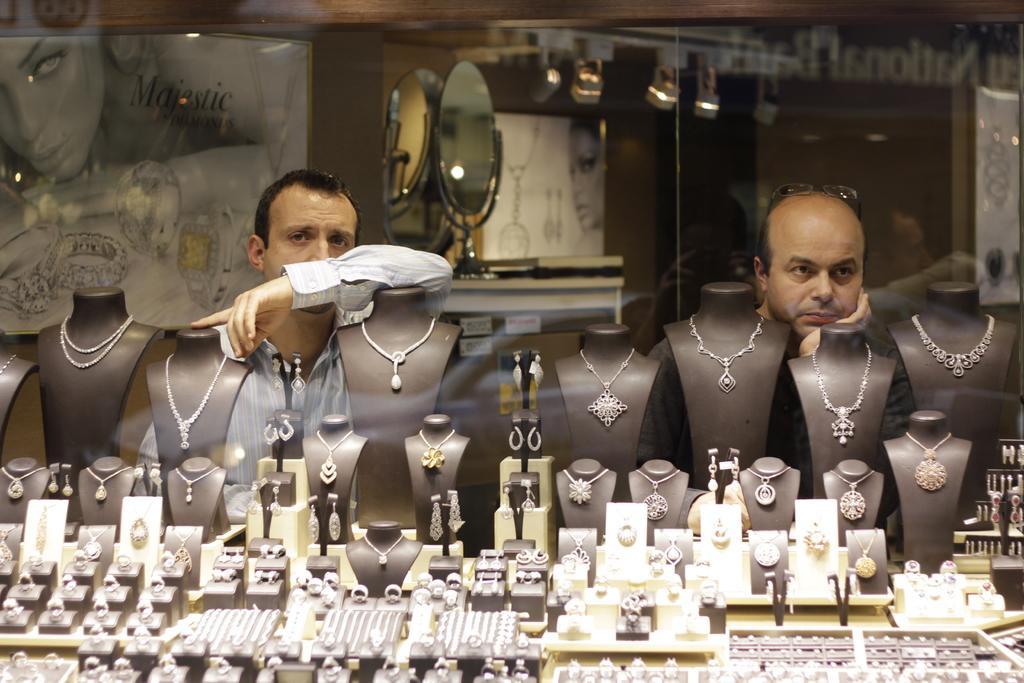Describe this image in one or two sentences. In this picture we can see jewelries in the jewelry stands. We can see two men. There is a mirror and some lights are visible on top. We can see a frame on the left side. In this frame, there is a woman, jewelries and some text. 